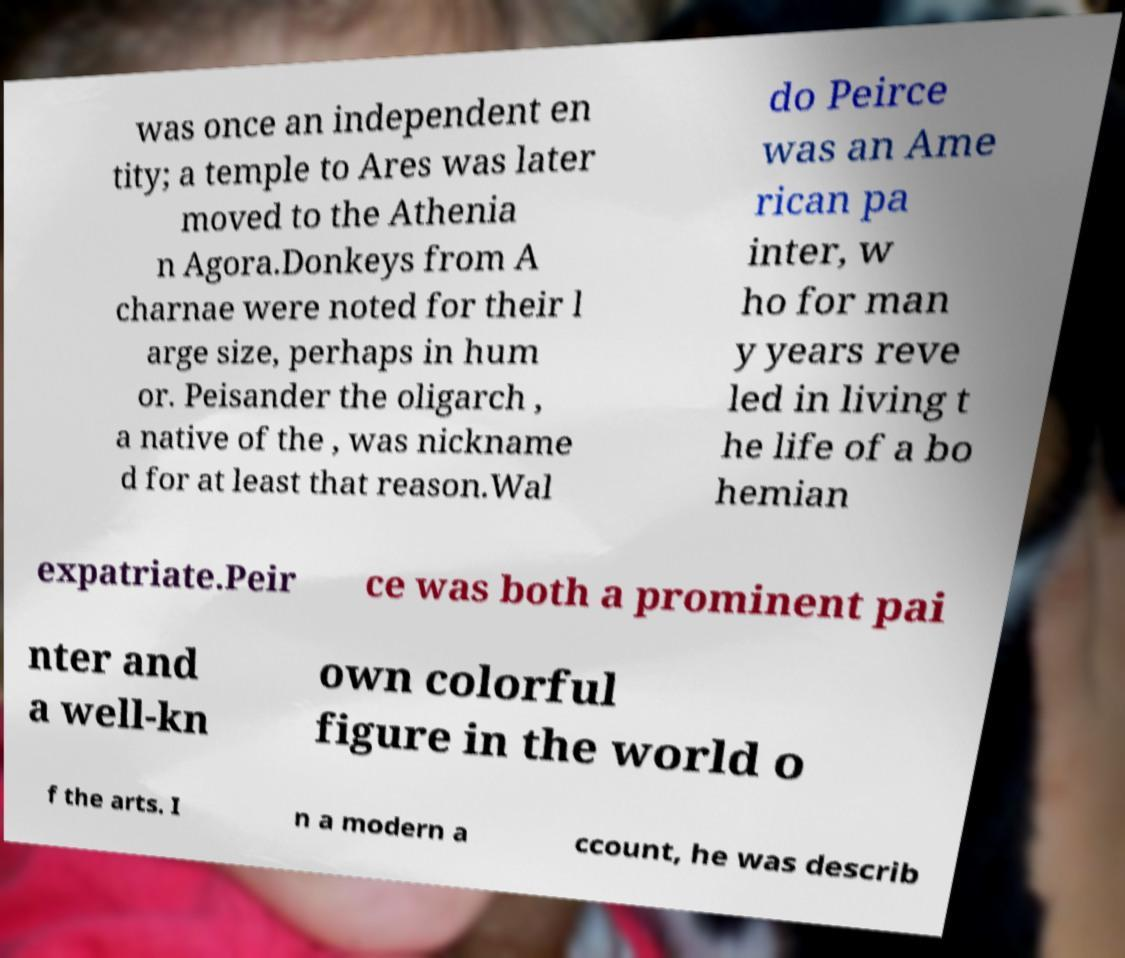Can you accurately transcribe the text from the provided image for me? was once an independent en tity; a temple to Ares was later moved to the Athenia n Agora.Donkeys from A charnae were noted for their l arge size, perhaps in hum or. Peisander the oligarch , a native of the , was nickname d for at least that reason.Wal do Peirce was an Ame rican pa inter, w ho for man y years reve led in living t he life of a bo hemian expatriate.Peir ce was both a prominent pai nter and a well-kn own colorful figure in the world o f the arts. I n a modern a ccount, he was describ 